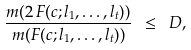Convert formula to latex. <formula><loc_0><loc_0><loc_500><loc_500>\frac { m ( 2 \, F ( c ; l _ { 1 } , \dots , l _ { t } ) ) } { m ( F ( c ; l _ { 1 } , \dots , l _ { t } ) ) } \ \leq \ D ,</formula> 